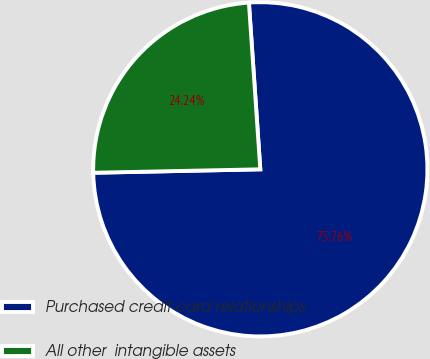<chart> <loc_0><loc_0><loc_500><loc_500><pie_chart><fcel>Purchased credit card relationships<fcel>All other  intangible assets<nl><fcel>75.76%<fcel>24.24%<nl></chart> 